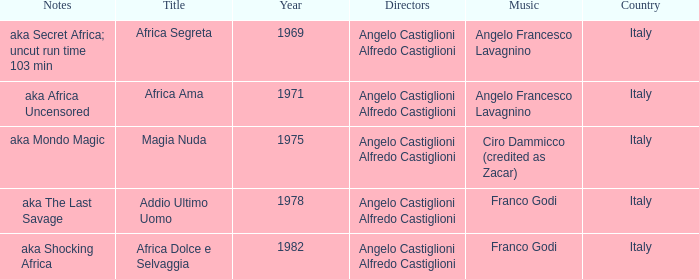How many years have a Title of Magia Nuda? 1.0. 